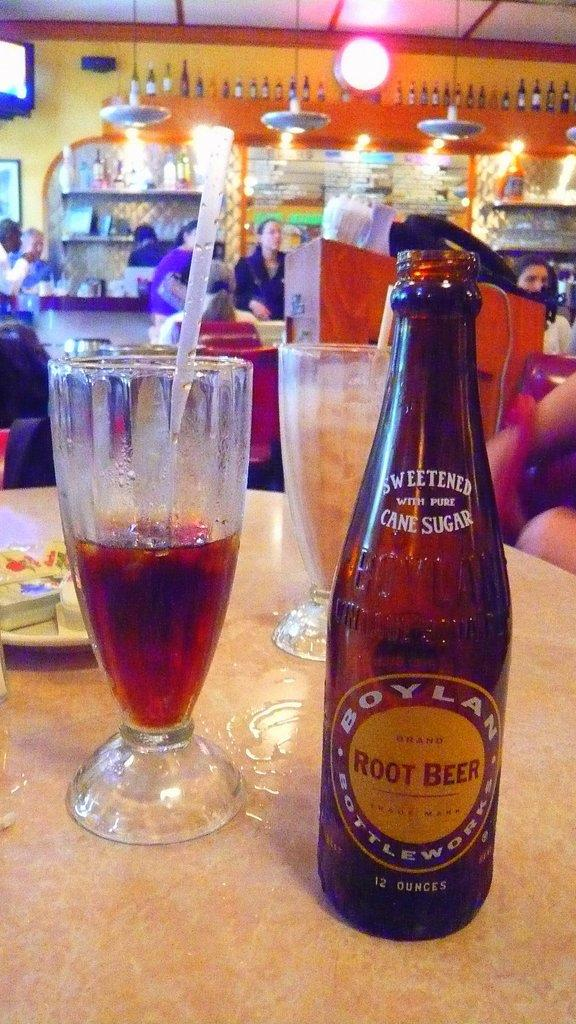Provide a one-sentence caption for the provided image. A bottle Boylan Root Beer on a table next two glasses of a half a glass of root beer with a straw in the glass. 